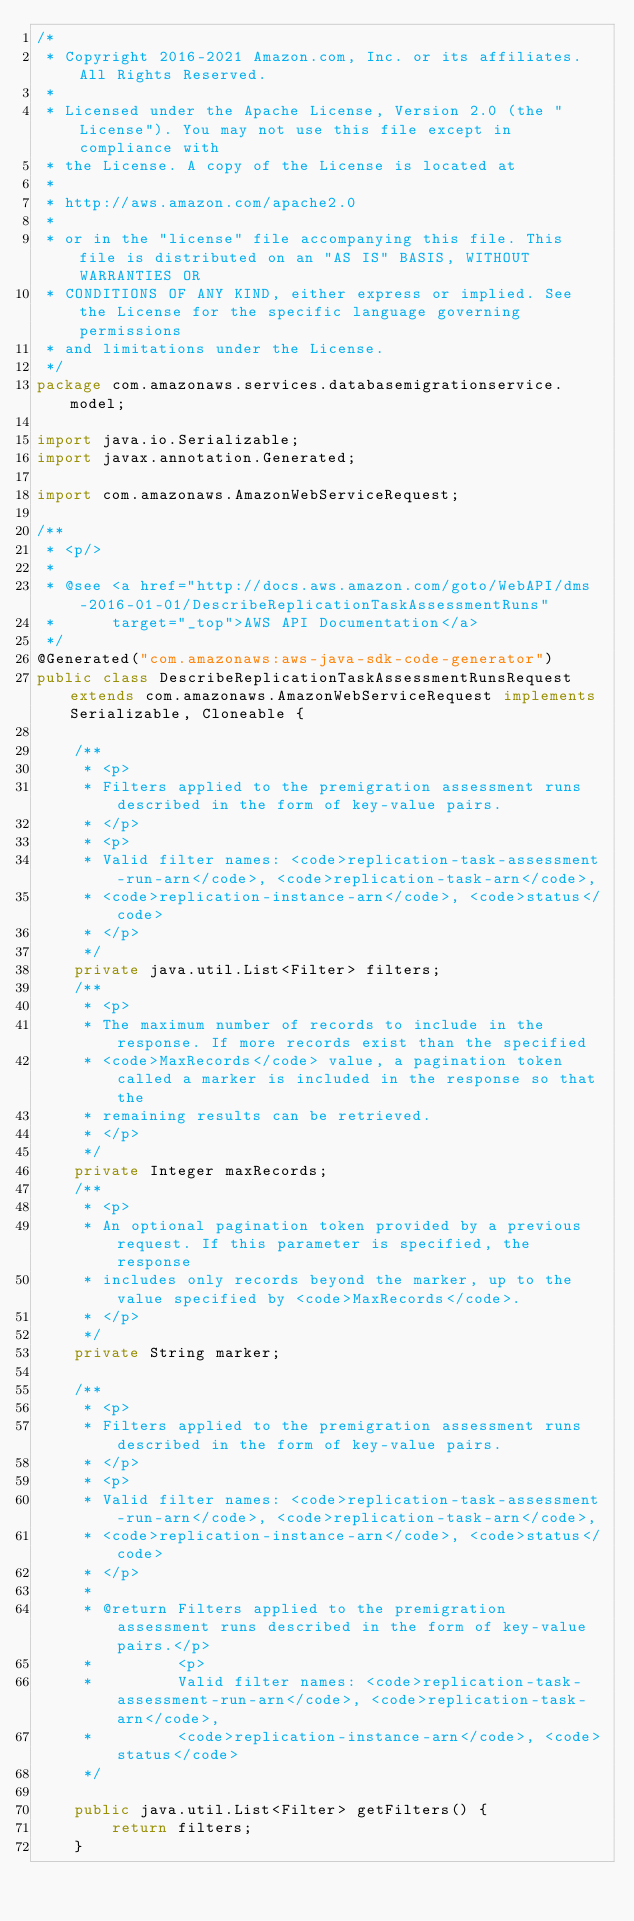<code> <loc_0><loc_0><loc_500><loc_500><_Java_>/*
 * Copyright 2016-2021 Amazon.com, Inc. or its affiliates. All Rights Reserved.
 * 
 * Licensed under the Apache License, Version 2.0 (the "License"). You may not use this file except in compliance with
 * the License. A copy of the License is located at
 * 
 * http://aws.amazon.com/apache2.0
 * 
 * or in the "license" file accompanying this file. This file is distributed on an "AS IS" BASIS, WITHOUT WARRANTIES OR
 * CONDITIONS OF ANY KIND, either express or implied. See the License for the specific language governing permissions
 * and limitations under the License.
 */
package com.amazonaws.services.databasemigrationservice.model;

import java.io.Serializable;
import javax.annotation.Generated;

import com.amazonaws.AmazonWebServiceRequest;

/**
 * <p/>
 * 
 * @see <a href="http://docs.aws.amazon.com/goto/WebAPI/dms-2016-01-01/DescribeReplicationTaskAssessmentRuns"
 *      target="_top">AWS API Documentation</a>
 */
@Generated("com.amazonaws:aws-java-sdk-code-generator")
public class DescribeReplicationTaskAssessmentRunsRequest extends com.amazonaws.AmazonWebServiceRequest implements Serializable, Cloneable {

    /**
     * <p>
     * Filters applied to the premigration assessment runs described in the form of key-value pairs.
     * </p>
     * <p>
     * Valid filter names: <code>replication-task-assessment-run-arn</code>, <code>replication-task-arn</code>,
     * <code>replication-instance-arn</code>, <code>status</code>
     * </p>
     */
    private java.util.List<Filter> filters;
    /**
     * <p>
     * The maximum number of records to include in the response. If more records exist than the specified
     * <code>MaxRecords</code> value, a pagination token called a marker is included in the response so that the
     * remaining results can be retrieved.
     * </p>
     */
    private Integer maxRecords;
    /**
     * <p>
     * An optional pagination token provided by a previous request. If this parameter is specified, the response
     * includes only records beyond the marker, up to the value specified by <code>MaxRecords</code>.
     * </p>
     */
    private String marker;

    /**
     * <p>
     * Filters applied to the premigration assessment runs described in the form of key-value pairs.
     * </p>
     * <p>
     * Valid filter names: <code>replication-task-assessment-run-arn</code>, <code>replication-task-arn</code>,
     * <code>replication-instance-arn</code>, <code>status</code>
     * </p>
     * 
     * @return Filters applied to the premigration assessment runs described in the form of key-value pairs.</p>
     *         <p>
     *         Valid filter names: <code>replication-task-assessment-run-arn</code>, <code>replication-task-arn</code>,
     *         <code>replication-instance-arn</code>, <code>status</code>
     */

    public java.util.List<Filter> getFilters() {
        return filters;
    }
</code> 